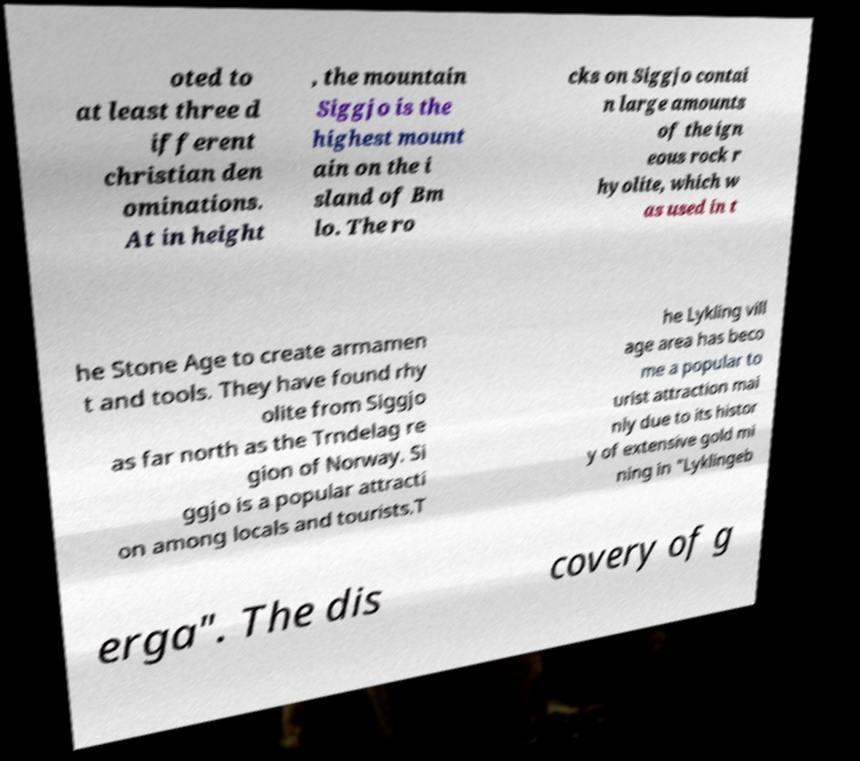I need the written content from this picture converted into text. Can you do that? oted to at least three d ifferent christian den ominations. At in height , the mountain Siggjo is the highest mount ain on the i sland of Bm lo. The ro cks on Siggjo contai n large amounts of the ign eous rock r hyolite, which w as used in t he Stone Age to create armamen t and tools. They have found rhy olite from Siggjo as far north as the Trndelag re gion of Norway. Si ggjo is a popular attracti on among locals and tourists.T he Lykling vill age area has beco me a popular to urist attraction mai nly due to its histor y of extensive gold mi ning in "Lyklingeb erga". The dis covery of g 